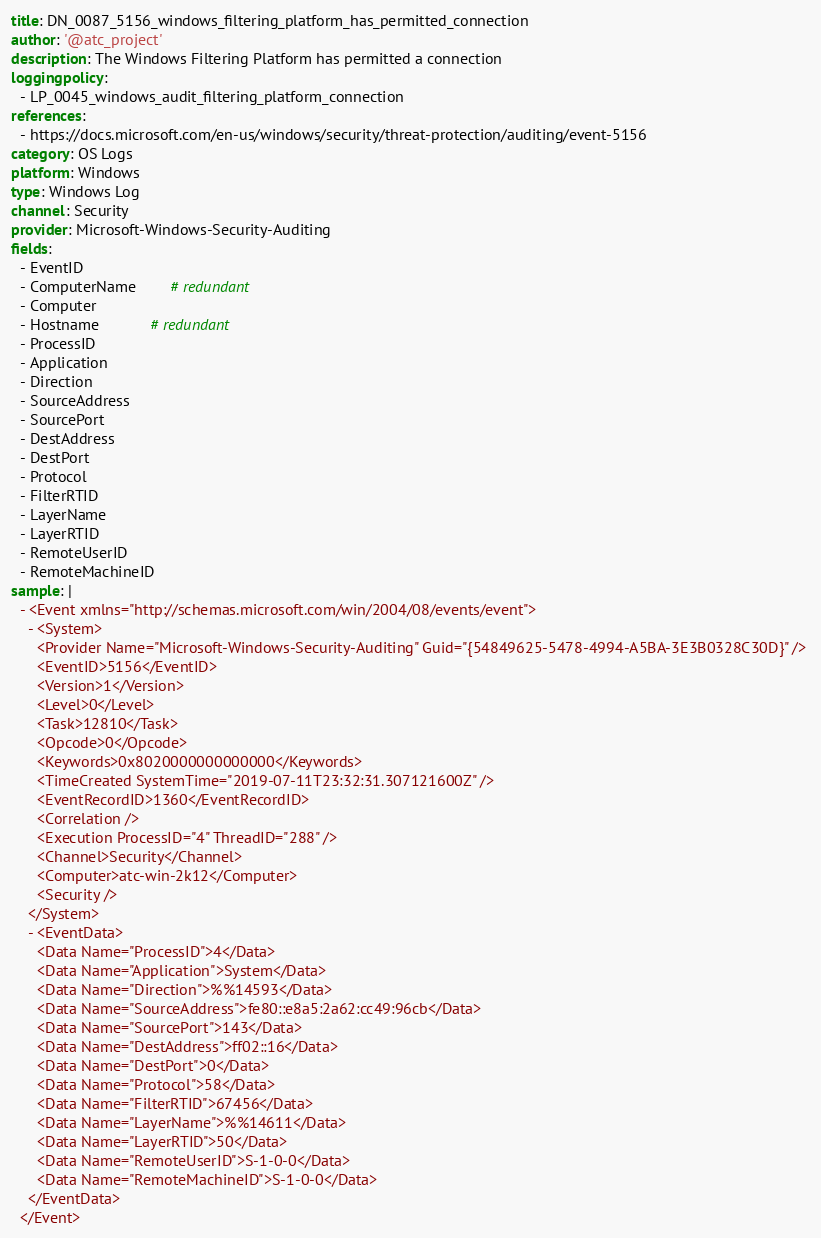Convert code to text. <code><loc_0><loc_0><loc_500><loc_500><_YAML_>title: DN_0087_5156_windows_filtering_platform_has_permitted_connection
author: '@atc_project'
description: The Windows Filtering Platform has permitted a connection
loggingpolicy: 
  - LP_0045_windows_audit_filtering_platform_connection
references: 
  - https://docs.microsoft.com/en-us/windows/security/threat-protection/auditing/event-5156
category: OS Logs
platform: Windows
type: Windows Log
channel: Security
provider: Microsoft-Windows-Security-Auditing
fields:
  - EventID
  - ComputerName        # redundant
  - Computer
  - Hostname            # redundant
  - ProcessID
  - Application
  - Direction
  - SourceAddress
  - SourcePort
  - DestAddress
  - DestPort
  - Protocol
  - FilterRTID
  - LayerName
  - LayerRTID
  - RemoteUserID
  - RemoteMachineID
sample: |
  - <Event xmlns="http://schemas.microsoft.com/win/2004/08/events/event">
    - <System>
      <Provider Name="Microsoft-Windows-Security-Auditing" Guid="{54849625-5478-4994-A5BA-3E3B0328C30D}" /> 
      <EventID>5156</EventID> 
      <Version>1</Version> 
      <Level>0</Level> 
      <Task>12810</Task> 
      <Opcode>0</Opcode> 
      <Keywords>0x8020000000000000</Keywords> 
      <TimeCreated SystemTime="2019-07-11T23:32:31.307121600Z" /> 
      <EventRecordID>1360</EventRecordID> 
      <Correlation /> 
      <Execution ProcessID="4" ThreadID="288" /> 
      <Channel>Security</Channel> 
      <Computer>atc-win-2k12</Computer> 
      <Security /> 
    </System>
    - <EventData>
      <Data Name="ProcessID">4</Data> 
      <Data Name="Application">System</Data> 
      <Data Name="Direction">%%14593</Data> 
      <Data Name="SourceAddress">fe80::e8a5:2a62:cc49:96cb</Data> 
      <Data Name="SourcePort">143</Data> 
      <Data Name="DestAddress">ff02::16</Data> 
      <Data Name="DestPort">0</Data> 
      <Data Name="Protocol">58</Data> 
      <Data Name="FilterRTID">67456</Data> 
      <Data Name="LayerName">%%14611</Data> 
      <Data Name="LayerRTID">50</Data> 
      <Data Name="RemoteUserID">S-1-0-0</Data> 
      <Data Name="RemoteMachineID">S-1-0-0</Data> 
    </EventData>
  </Event>
</code> 